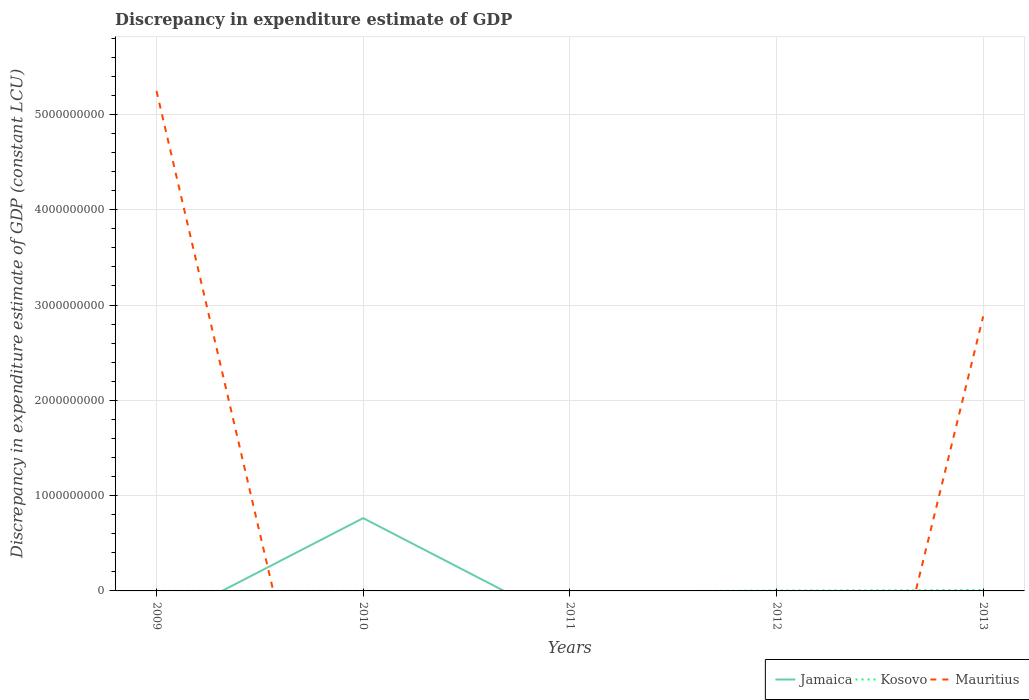How many different coloured lines are there?
Offer a terse response. 3. Is the number of lines equal to the number of legend labels?
Your answer should be very brief. No. What is the total discrepancy in expenditure estimate of GDP in Mauritius in the graph?
Ensure brevity in your answer.  2.37e+09. What is the difference between the highest and the second highest discrepancy in expenditure estimate of GDP in Jamaica?
Your response must be concise. 7.64e+08. What is the difference between the highest and the lowest discrepancy in expenditure estimate of GDP in Jamaica?
Make the answer very short. 1. How many years are there in the graph?
Offer a terse response. 5. What is the difference between two consecutive major ticks on the Y-axis?
Keep it short and to the point. 1.00e+09. Are the values on the major ticks of Y-axis written in scientific E-notation?
Offer a terse response. No. Does the graph contain any zero values?
Keep it short and to the point. Yes. How many legend labels are there?
Your answer should be compact. 3. How are the legend labels stacked?
Offer a terse response. Horizontal. What is the title of the graph?
Your response must be concise. Discrepancy in expenditure estimate of GDP. What is the label or title of the Y-axis?
Provide a succinct answer. Discrepancy in expenditure estimate of GDP (constant LCU). What is the Discrepancy in expenditure estimate of GDP (constant LCU) in Kosovo in 2009?
Provide a succinct answer. 1.00e+05. What is the Discrepancy in expenditure estimate of GDP (constant LCU) of Mauritius in 2009?
Offer a very short reply. 5.25e+09. What is the Discrepancy in expenditure estimate of GDP (constant LCU) of Jamaica in 2010?
Your answer should be compact. 7.64e+08. What is the Discrepancy in expenditure estimate of GDP (constant LCU) in Kosovo in 2010?
Your answer should be very brief. 2.00e+05. What is the Discrepancy in expenditure estimate of GDP (constant LCU) of Mauritius in 2010?
Give a very brief answer. 0. What is the Discrepancy in expenditure estimate of GDP (constant LCU) of Jamaica in 2011?
Your answer should be very brief. 0. What is the Discrepancy in expenditure estimate of GDP (constant LCU) in Kosovo in 2011?
Offer a very short reply. 0. What is the Discrepancy in expenditure estimate of GDP (constant LCU) in Mauritius in 2011?
Ensure brevity in your answer.  0. What is the Discrepancy in expenditure estimate of GDP (constant LCU) of Kosovo in 2012?
Offer a terse response. 3.90e+06. What is the Discrepancy in expenditure estimate of GDP (constant LCU) of Mauritius in 2012?
Offer a terse response. 0. What is the Discrepancy in expenditure estimate of GDP (constant LCU) in Jamaica in 2013?
Provide a short and direct response. 0. What is the Discrepancy in expenditure estimate of GDP (constant LCU) in Kosovo in 2013?
Keep it short and to the point. 8.20e+06. What is the Discrepancy in expenditure estimate of GDP (constant LCU) in Mauritius in 2013?
Offer a terse response. 2.88e+09. Across all years, what is the maximum Discrepancy in expenditure estimate of GDP (constant LCU) of Jamaica?
Provide a short and direct response. 7.64e+08. Across all years, what is the maximum Discrepancy in expenditure estimate of GDP (constant LCU) of Kosovo?
Ensure brevity in your answer.  8.20e+06. Across all years, what is the maximum Discrepancy in expenditure estimate of GDP (constant LCU) in Mauritius?
Your answer should be compact. 5.25e+09. Across all years, what is the minimum Discrepancy in expenditure estimate of GDP (constant LCU) of Jamaica?
Make the answer very short. 0. What is the total Discrepancy in expenditure estimate of GDP (constant LCU) of Jamaica in the graph?
Give a very brief answer. 7.64e+08. What is the total Discrepancy in expenditure estimate of GDP (constant LCU) of Kosovo in the graph?
Give a very brief answer. 1.24e+07. What is the total Discrepancy in expenditure estimate of GDP (constant LCU) of Mauritius in the graph?
Your answer should be compact. 8.13e+09. What is the difference between the Discrepancy in expenditure estimate of GDP (constant LCU) in Kosovo in 2009 and that in 2012?
Ensure brevity in your answer.  -3.80e+06. What is the difference between the Discrepancy in expenditure estimate of GDP (constant LCU) in Kosovo in 2009 and that in 2013?
Your answer should be compact. -8.10e+06. What is the difference between the Discrepancy in expenditure estimate of GDP (constant LCU) in Mauritius in 2009 and that in 2013?
Provide a short and direct response. 2.37e+09. What is the difference between the Discrepancy in expenditure estimate of GDP (constant LCU) in Kosovo in 2010 and that in 2012?
Provide a short and direct response. -3.70e+06. What is the difference between the Discrepancy in expenditure estimate of GDP (constant LCU) of Kosovo in 2010 and that in 2013?
Offer a very short reply. -8.00e+06. What is the difference between the Discrepancy in expenditure estimate of GDP (constant LCU) in Kosovo in 2012 and that in 2013?
Your answer should be very brief. -4.30e+06. What is the difference between the Discrepancy in expenditure estimate of GDP (constant LCU) of Kosovo in 2009 and the Discrepancy in expenditure estimate of GDP (constant LCU) of Mauritius in 2013?
Give a very brief answer. -2.88e+09. What is the difference between the Discrepancy in expenditure estimate of GDP (constant LCU) in Jamaica in 2010 and the Discrepancy in expenditure estimate of GDP (constant LCU) in Kosovo in 2012?
Keep it short and to the point. 7.60e+08. What is the difference between the Discrepancy in expenditure estimate of GDP (constant LCU) of Jamaica in 2010 and the Discrepancy in expenditure estimate of GDP (constant LCU) of Kosovo in 2013?
Your response must be concise. 7.56e+08. What is the difference between the Discrepancy in expenditure estimate of GDP (constant LCU) of Jamaica in 2010 and the Discrepancy in expenditure estimate of GDP (constant LCU) of Mauritius in 2013?
Offer a very short reply. -2.12e+09. What is the difference between the Discrepancy in expenditure estimate of GDP (constant LCU) of Kosovo in 2010 and the Discrepancy in expenditure estimate of GDP (constant LCU) of Mauritius in 2013?
Offer a terse response. -2.88e+09. What is the difference between the Discrepancy in expenditure estimate of GDP (constant LCU) of Kosovo in 2012 and the Discrepancy in expenditure estimate of GDP (constant LCU) of Mauritius in 2013?
Provide a succinct answer. -2.88e+09. What is the average Discrepancy in expenditure estimate of GDP (constant LCU) in Jamaica per year?
Keep it short and to the point. 1.53e+08. What is the average Discrepancy in expenditure estimate of GDP (constant LCU) of Kosovo per year?
Keep it short and to the point. 2.48e+06. What is the average Discrepancy in expenditure estimate of GDP (constant LCU) of Mauritius per year?
Ensure brevity in your answer.  1.63e+09. In the year 2009, what is the difference between the Discrepancy in expenditure estimate of GDP (constant LCU) in Kosovo and Discrepancy in expenditure estimate of GDP (constant LCU) in Mauritius?
Keep it short and to the point. -5.25e+09. In the year 2010, what is the difference between the Discrepancy in expenditure estimate of GDP (constant LCU) in Jamaica and Discrepancy in expenditure estimate of GDP (constant LCU) in Kosovo?
Your answer should be very brief. 7.64e+08. In the year 2013, what is the difference between the Discrepancy in expenditure estimate of GDP (constant LCU) in Kosovo and Discrepancy in expenditure estimate of GDP (constant LCU) in Mauritius?
Give a very brief answer. -2.87e+09. What is the ratio of the Discrepancy in expenditure estimate of GDP (constant LCU) in Kosovo in 2009 to that in 2012?
Offer a terse response. 0.03. What is the ratio of the Discrepancy in expenditure estimate of GDP (constant LCU) of Kosovo in 2009 to that in 2013?
Your response must be concise. 0.01. What is the ratio of the Discrepancy in expenditure estimate of GDP (constant LCU) of Mauritius in 2009 to that in 2013?
Provide a short and direct response. 1.82. What is the ratio of the Discrepancy in expenditure estimate of GDP (constant LCU) of Kosovo in 2010 to that in 2012?
Make the answer very short. 0.05. What is the ratio of the Discrepancy in expenditure estimate of GDP (constant LCU) of Kosovo in 2010 to that in 2013?
Your response must be concise. 0.02. What is the ratio of the Discrepancy in expenditure estimate of GDP (constant LCU) of Kosovo in 2012 to that in 2013?
Ensure brevity in your answer.  0.48. What is the difference between the highest and the second highest Discrepancy in expenditure estimate of GDP (constant LCU) of Kosovo?
Make the answer very short. 4.30e+06. What is the difference between the highest and the lowest Discrepancy in expenditure estimate of GDP (constant LCU) of Jamaica?
Ensure brevity in your answer.  7.64e+08. What is the difference between the highest and the lowest Discrepancy in expenditure estimate of GDP (constant LCU) in Kosovo?
Offer a terse response. 8.20e+06. What is the difference between the highest and the lowest Discrepancy in expenditure estimate of GDP (constant LCU) in Mauritius?
Your response must be concise. 5.25e+09. 